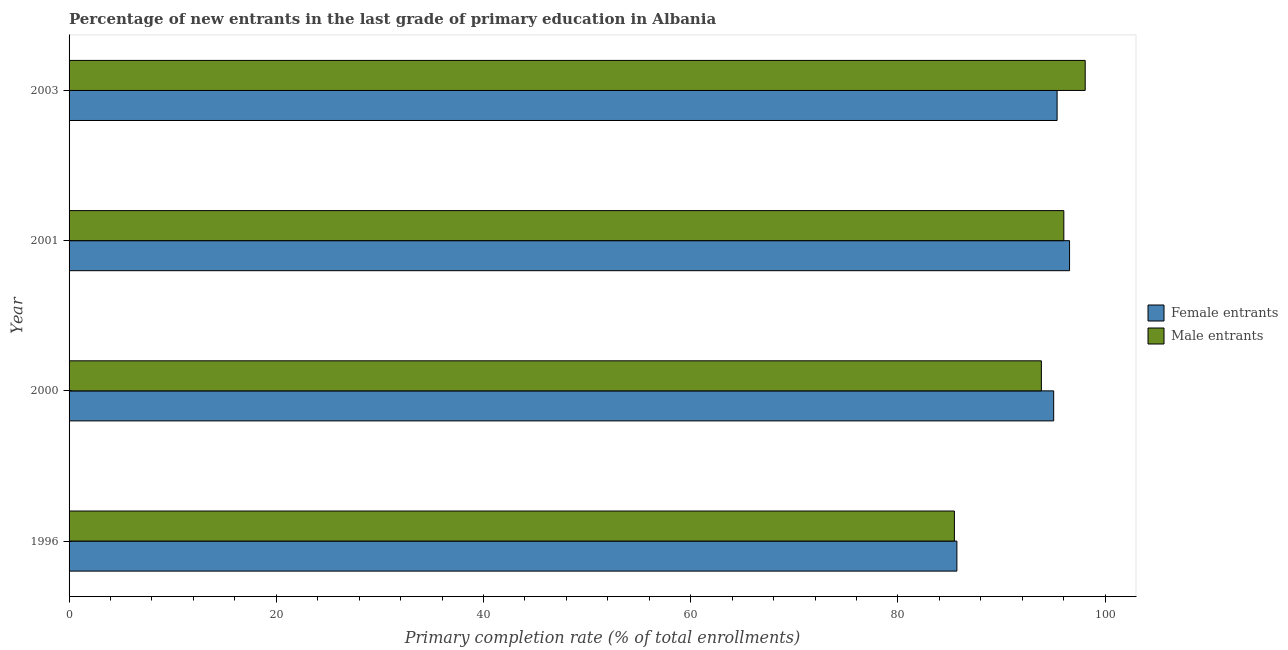How many different coloured bars are there?
Make the answer very short. 2. How many groups of bars are there?
Your answer should be compact. 4. Are the number of bars on each tick of the Y-axis equal?
Make the answer very short. Yes. How many bars are there on the 2nd tick from the top?
Your answer should be compact. 2. How many bars are there on the 1st tick from the bottom?
Keep it short and to the point. 2. What is the primary completion rate of male entrants in 2000?
Provide a succinct answer. 93.85. Across all years, what is the maximum primary completion rate of female entrants?
Give a very brief answer. 96.57. Across all years, what is the minimum primary completion rate of male entrants?
Your answer should be very brief. 85.45. In which year was the primary completion rate of female entrants maximum?
Provide a short and direct response. 2001. What is the total primary completion rate of male entrants in the graph?
Offer a terse response. 373.4. What is the difference between the primary completion rate of male entrants in 1996 and that in 2000?
Ensure brevity in your answer.  -8.39. What is the difference between the primary completion rate of female entrants in 2003 and the primary completion rate of male entrants in 2001?
Provide a short and direct response. -0.65. What is the average primary completion rate of male entrants per year?
Offer a terse response. 93.35. In the year 2000, what is the difference between the primary completion rate of male entrants and primary completion rate of female entrants?
Offer a terse response. -1.19. What is the ratio of the primary completion rate of female entrants in 2000 to that in 2001?
Provide a succinct answer. 0.98. Is the primary completion rate of female entrants in 1996 less than that in 2000?
Ensure brevity in your answer.  Yes. Is the difference between the primary completion rate of female entrants in 1996 and 2000 greater than the difference between the primary completion rate of male entrants in 1996 and 2000?
Offer a very short reply. No. What is the difference between the highest and the second highest primary completion rate of male entrants?
Your answer should be compact. 2.06. What is the difference between the highest and the lowest primary completion rate of female entrants?
Your answer should be compact. 10.87. Is the sum of the primary completion rate of male entrants in 2000 and 2003 greater than the maximum primary completion rate of female entrants across all years?
Offer a very short reply. Yes. What does the 1st bar from the top in 1996 represents?
Offer a terse response. Male entrants. What does the 1st bar from the bottom in 2001 represents?
Your response must be concise. Female entrants. How many bars are there?
Your answer should be very brief. 8. Are all the bars in the graph horizontal?
Offer a terse response. Yes. What is the difference between two consecutive major ticks on the X-axis?
Keep it short and to the point. 20. Are the values on the major ticks of X-axis written in scientific E-notation?
Offer a very short reply. No. Does the graph contain any zero values?
Your answer should be very brief. No. Does the graph contain grids?
Provide a succinct answer. No. Where does the legend appear in the graph?
Provide a succinct answer. Center right. What is the title of the graph?
Provide a succinct answer. Percentage of new entrants in the last grade of primary education in Albania. What is the label or title of the X-axis?
Keep it short and to the point. Primary completion rate (% of total enrollments). What is the label or title of the Y-axis?
Your response must be concise. Year. What is the Primary completion rate (% of total enrollments) in Female entrants in 1996?
Your answer should be compact. 85.69. What is the Primary completion rate (% of total enrollments) of Male entrants in 1996?
Your response must be concise. 85.45. What is the Primary completion rate (% of total enrollments) of Female entrants in 2000?
Keep it short and to the point. 95.04. What is the Primary completion rate (% of total enrollments) in Male entrants in 2000?
Make the answer very short. 93.85. What is the Primary completion rate (% of total enrollments) in Female entrants in 2001?
Your response must be concise. 96.57. What is the Primary completion rate (% of total enrollments) of Male entrants in 2001?
Your answer should be compact. 96.02. What is the Primary completion rate (% of total enrollments) in Female entrants in 2003?
Give a very brief answer. 95.37. What is the Primary completion rate (% of total enrollments) of Male entrants in 2003?
Give a very brief answer. 98.08. Across all years, what is the maximum Primary completion rate (% of total enrollments) of Female entrants?
Give a very brief answer. 96.57. Across all years, what is the maximum Primary completion rate (% of total enrollments) in Male entrants?
Your answer should be very brief. 98.08. Across all years, what is the minimum Primary completion rate (% of total enrollments) in Female entrants?
Offer a terse response. 85.69. Across all years, what is the minimum Primary completion rate (% of total enrollments) in Male entrants?
Your answer should be compact. 85.45. What is the total Primary completion rate (% of total enrollments) of Female entrants in the graph?
Your answer should be very brief. 372.67. What is the total Primary completion rate (% of total enrollments) in Male entrants in the graph?
Offer a terse response. 373.4. What is the difference between the Primary completion rate (% of total enrollments) in Female entrants in 1996 and that in 2000?
Your answer should be compact. -9.34. What is the difference between the Primary completion rate (% of total enrollments) in Male entrants in 1996 and that in 2000?
Offer a very short reply. -8.39. What is the difference between the Primary completion rate (% of total enrollments) of Female entrants in 1996 and that in 2001?
Provide a succinct answer. -10.87. What is the difference between the Primary completion rate (% of total enrollments) in Male entrants in 1996 and that in 2001?
Provide a short and direct response. -10.56. What is the difference between the Primary completion rate (% of total enrollments) of Female entrants in 1996 and that in 2003?
Offer a terse response. -9.67. What is the difference between the Primary completion rate (% of total enrollments) of Male entrants in 1996 and that in 2003?
Provide a succinct answer. -12.63. What is the difference between the Primary completion rate (% of total enrollments) in Female entrants in 2000 and that in 2001?
Provide a short and direct response. -1.53. What is the difference between the Primary completion rate (% of total enrollments) of Male entrants in 2000 and that in 2001?
Your response must be concise. -2.17. What is the difference between the Primary completion rate (% of total enrollments) in Female entrants in 2000 and that in 2003?
Offer a terse response. -0.33. What is the difference between the Primary completion rate (% of total enrollments) in Male entrants in 2000 and that in 2003?
Make the answer very short. -4.23. What is the difference between the Primary completion rate (% of total enrollments) of Female entrants in 2001 and that in 2003?
Ensure brevity in your answer.  1.2. What is the difference between the Primary completion rate (% of total enrollments) of Male entrants in 2001 and that in 2003?
Give a very brief answer. -2.06. What is the difference between the Primary completion rate (% of total enrollments) in Female entrants in 1996 and the Primary completion rate (% of total enrollments) in Male entrants in 2000?
Your answer should be compact. -8.15. What is the difference between the Primary completion rate (% of total enrollments) of Female entrants in 1996 and the Primary completion rate (% of total enrollments) of Male entrants in 2001?
Provide a succinct answer. -10.32. What is the difference between the Primary completion rate (% of total enrollments) in Female entrants in 1996 and the Primary completion rate (% of total enrollments) in Male entrants in 2003?
Make the answer very short. -12.39. What is the difference between the Primary completion rate (% of total enrollments) of Female entrants in 2000 and the Primary completion rate (% of total enrollments) of Male entrants in 2001?
Your answer should be compact. -0.98. What is the difference between the Primary completion rate (% of total enrollments) in Female entrants in 2000 and the Primary completion rate (% of total enrollments) in Male entrants in 2003?
Offer a very short reply. -3.04. What is the difference between the Primary completion rate (% of total enrollments) in Female entrants in 2001 and the Primary completion rate (% of total enrollments) in Male entrants in 2003?
Make the answer very short. -1.51. What is the average Primary completion rate (% of total enrollments) in Female entrants per year?
Offer a terse response. 93.17. What is the average Primary completion rate (% of total enrollments) of Male entrants per year?
Your answer should be very brief. 93.35. In the year 1996, what is the difference between the Primary completion rate (% of total enrollments) in Female entrants and Primary completion rate (% of total enrollments) in Male entrants?
Your answer should be compact. 0.24. In the year 2000, what is the difference between the Primary completion rate (% of total enrollments) in Female entrants and Primary completion rate (% of total enrollments) in Male entrants?
Provide a short and direct response. 1.19. In the year 2001, what is the difference between the Primary completion rate (% of total enrollments) of Female entrants and Primary completion rate (% of total enrollments) of Male entrants?
Provide a succinct answer. 0.55. In the year 2003, what is the difference between the Primary completion rate (% of total enrollments) in Female entrants and Primary completion rate (% of total enrollments) in Male entrants?
Offer a terse response. -2.71. What is the ratio of the Primary completion rate (% of total enrollments) in Female entrants in 1996 to that in 2000?
Give a very brief answer. 0.9. What is the ratio of the Primary completion rate (% of total enrollments) in Male entrants in 1996 to that in 2000?
Your answer should be very brief. 0.91. What is the ratio of the Primary completion rate (% of total enrollments) in Female entrants in 1996 to that in 2001?
Ensure brevity in your answer.  0.89. What is the ratio of the Primary completion rate (% of total enrollments) in Male entrants in 1996 to that in 2001?
Offer a very short reply. 0.89. What is the ratio of the Primary completion rate (% of total enrollments) of Female entrants in 1996 to that in 2003?
Make the answer very short. 0.9. What is the ratio of the Primary completion rate (% of total enrollments) of Male entrants in 1996 to that in 2003?
Offer a very short reply. 0.87. What is the ratio of the Primary completion rate (% of total enrollments) of Female entrants in 2000 to that in 2001?
Ensure brevity in your answer.  0.98. What is the ratio of the Primary completion rate (% of total enrollments) in Male entrants in 2000 to that in 2001?
Keep it short and to the point. 0.98. What is the ratio of the Primary completion rate (% of total enrollments) in Female entrants in 2000 to that in 2003?
Make the answer very short. 1. What is the ratio of the Primary completion rate (% of total enrollments) in Male entrants in 2000 to that in 2003?
Provide a short and direct response. 0.96. What is the ratio of the Primary completion rate (% of total enrollments) in Female entrants in 2001 to that in 2003?
Provide a succinct answer. 1.01. What is the difference between the highest and the second highest Primary completion rate (% of total enrollments) of Female entrants?
Your answer should be compact. 1.2. What is the difference between the highest and the second highest Primary completion rate (% of total enrollments) in Male entrants?
Give a very brief answer. 2.06. What is the difference between the highest and the lowest Primary completion rate (% of total enrollments) of Female entrants?
Offer a terse response. 10.87. What is the difference between the highest and the lowest Primary completion rate (% of total enrollments) of Male entrants?
Your response must be concise. 12.63. 